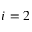<formula> <loc_0><loc_0><loc_500><loc_500>i = 2</formula> 